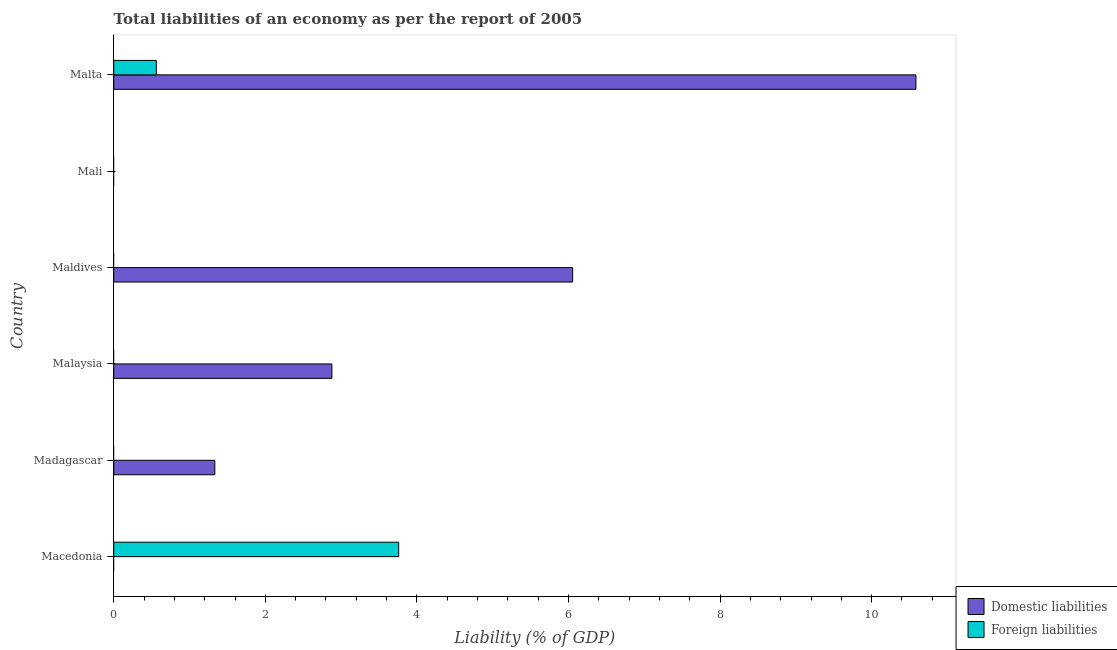Are the number of bars on each tick of the Y-axis equal?
Your response must be concise. No. What is the label of the 4th group of bars from the top?
Offer a very short reply. Malaysia. In how many cases, is the number of bars for a given country not equal to the number of legend labels?
Give a very brief answer. 5. What is the incurrence of foreign liabilities in Mali?
Provide a short and direct response. 0. Across all countries, what is the maximum incurrence of domestic liabilities?
Keep it short and to the point. 10.58. Across all countries, what is the minimum incurrence of foreign liabilities?
Make the answer very short. 0. In which country was the incurrence of domestic liabilities maximum?
Provide a short and direct response. Malta. What is the total incurrence of foreign liabilities in the graph?
Give a very brief answer. 4.32. What is the difference between the incurrence of domestic liabilities in Madagascar and that in Malta?
Give a very brief answer. -9.25. What is the difference between the incurrence of domestic liabilities in Malaysia and the incurrence of foreign liabilities in Macedonia?
Offer a very short reply. -0.88. What is the average incurrence of domestic liabilities per country?
Your response must be concise. 3.48. What is the difference between the incurrence of foreign liabilities and incurrence of domestic liabilities in Malta?
Your answer should be very brief. -10.02. What is the ratio of the incurrence of foreign liabilities in Macedonia to that in Malta?
Your answer should be very brief. 6.69. Is the incurrence of domestic liabilities in Madagascar less than that in Malaysia?
Your answer should be very brief. Yes. What is the difference between the highest and the second highest incurrence of domestic liabilities?
Give a very brief answer. 4.53. What is the difference between the highest and the lowest incurrence of domestic liabilities?
Give a very brief answer. 10.58. In how many countries, is the incurrence of domestic liabilities greater than the average incurrence of domestic liabilities taken over all countries?
Your answer should be compact. 2. Are all the bars in the graph horizontal?
Provide a succinct answer. Yes. How many countries are there in the graph?
Your answer should be compact. 6. What is the difference between two consecutive major ticks on the X-axis?
Your answer should be very brief. 2. Where does the legend appear in the graph?
Provide a succinct answer. Bottom right. How many legend labels are there?
Give a very brief answer. 2. How are the legend labels stacked?
Your answer should be very brief. Vertical. What is the title of the graph?
Provide a short and direct response. Total liabilities of an economy as per the report of 2005. What is the label or title of the X-axis?
Offer a terse response. Liability (% of GDP). What is the Liability (% of GDP) in Foreign liabilities in Macedonia?
Give a very brief answer. 3.76. What is the Liability (% of GDP) in Domestic liabilities in Madagascar?
Offer a very short reply. 1.33. What is the Liability (% of GDP) in Foreign liabilities in Madagascar?
Offer a terse response. 0. What is the Liability (% of GDP) in Domestic liabilities in Malaysia?
Make the answer very short. 2.88. What is the Liability (% of GDP) in Domestic liabilities in Maldives?
Give a very brief answer. 6.06. What is the Liability (% of GDP) in Foreign liabilities in Maldives?
Your answer should be very brief. 0. What is the Liability (% of GDP) of Domestic liabilities in Mali?
Your response must be concise. 0. What is the Liability (% of GDP) in Domestic liabilities in Malta?
Give a very brief answer. 10.58. What is the Liability (% of GDP) of Foreign liabilities in Malta?
Offer a terse response. 0.56. Across all countries, what is the maximum Liability (% of GDP) in Domestic liabilities?
Your answer should be very brief. 10.58. Across all countries, what is the maximum Liability (% of GDP) of Foreign liabilities?
Provide a succinct answer. 3.76. Across all countries, what is the minimum Liability (% of GDP) of Domestic liabilities?
Your answer should be compact. 0. Across all countries, what is the minimum Liability (% of GDP) in Foreign liabilities?
Make the answer very short. 0. What is the total Liability (% of GDP) of Domestic liabilities in the graph?
Offer a terse response. 20.85. What is the total Liability (% of GDP) of Foreign liabilities in the graph?
Give a very brief answer. 4.32. What is the difference between the Liability (% of GDP) of Foreign liabilities in Macedonia and that in Malta?
Provide a short and direct response. 3.2. What is the difference between the Liability (% of GDP) in Domestic liabilities in Madagascar and that in Malaysia?
Offer a terse response. -1.54. What is the difference between the Liability (% of GDP) of Domestic liabilities in Madagascar and that in Maldives?
Offer a terse response. -4.72. What is the difference between the Liability (% of GDP) in Domestic liabilities in Madagascar and that in Malta?
Make the answer very short. -9.25. What is the difference between the Liability (% of GDP) of Domestic liabilities in Malaysia and that in Maldives?
Your response must be concise. -3.18. What is the difference between the Liability (% of GDP) of Domestic liabilities in Malaysia and that in Malta?
Ensure brevity in your answer.  -7.71. What is the difference between the Liability (% of GDP) of Domestic liabilities in Maldives and that in Malta?
Provide a short and direct response. -4.53. What is the difference between the Liability (% of GDP) in Domestic liabilities in Madagascar and the Liability (% of GDP) in Foreign liabilities in Malta?
Provide a succinct answer. 0.77. What is the difference between the Liability (% of GDP) of Domestic liabilities in Malaysia and the Liability (% of GDP) of Foreign liabilities in Malta?
Your response must be concise. 2.32. What is the difference between the Liability (% of GDP) of Domestic liabilities in Maldives and the Liability (% of GDP) of Foreign liabilities in Malta?
Provide a short and direct response. 5.49. What is the average Liability (% of GDP) in Domestic liabilities per country?
Provide a short and direct response. 3.48. What is the average Liability (% of GDP) in Foreign liabilities per country?
Offer a very short reply. 0.72. What is the difference between the Liability (% of GDP) of Domestic liabilities and Liability (% of GDP) of Foreign liabilities in Malta?
Your answer should be very brief. 10.02. What is the ratio of the Liability (% of GDP) of Foreign liabilities in Macedonia to that in Malta?
Offer a terse response. 6.69. What is the ratio of the Liability (% of GDP) of Domestic liabilities in Madagascar to that in Malaysia?
Your answer should be compact. 0.46. What is the ratio of the Liability (% of GDP) of Domestic liabilities in Madagascar to that in Maldives?
Ensure brevity in your answer.  0.22. What is the ratio of the Liability (% of GDP) in Domestic liabilities in Madagascar to that in Malta?
Your answer should be compact. 0.13. What is the ratio of the Liability (% of GDP) in Domestic liabilities in Malaysia to that in Maldives?
Keep it short and to the point. 0.48. What is the ratio of the Liability (% of GDP) in Domestic liabilities in Malaysia to that in Malta?
Your response must be concise. 0.27. What is the ratio of the Liability (% of GDP) in Domestic liabilities in Maldives to that in Malta?
Your answer should be compact. 0.57. What is the difference between the highest and the second highest Liability (% of GDP) of Domestic liabilities?
Make the answer very short. 4.53. What is the difference between the highest and the lowest Liability (% of GDP) in Domestic liabilities?
Keep it short and to the point. 10.58. What is the difference between the highest and the lowest Liability (% of GDP) in Foreign liabilities?
Ensure brevity in your answer.  3.76. 